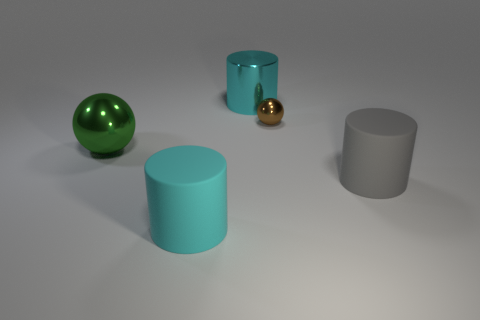Are the objects in the image arranged in a specific pattern or sequence? The objects appear to be deliberately arranged with adequate spacing to showcase their individual shapes and colors. However, there is no apparent sequence that follows a mathematical or straightforward pattern, as the objects vary in size, color, and positioning, possibly to highlight their differences. 